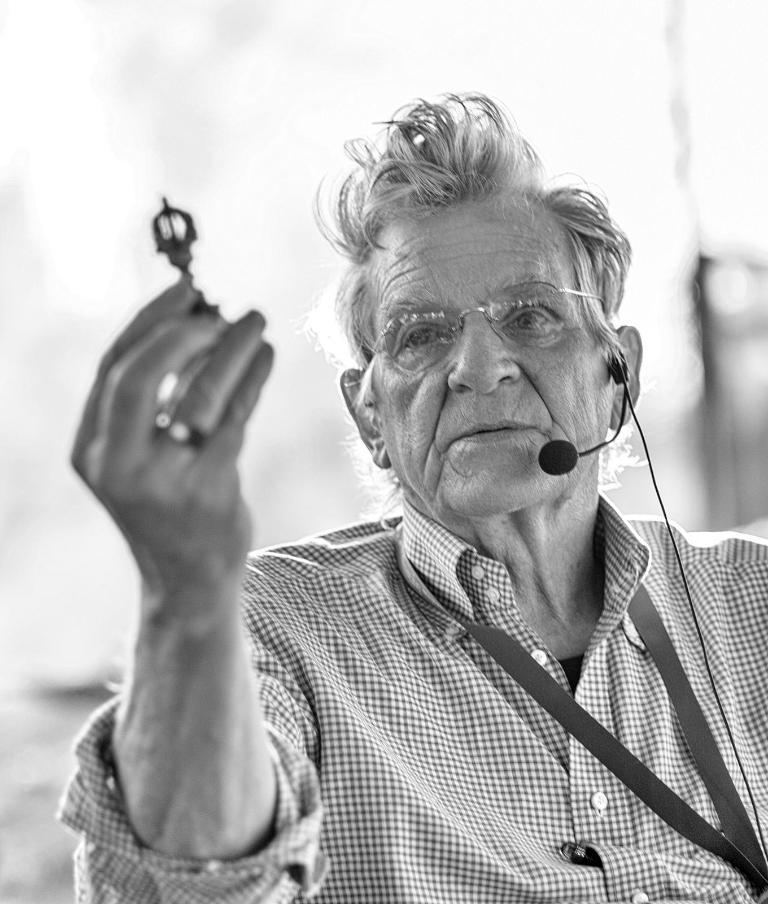What is the color scheme of the image? The image is black and white. Who is the main subject in the image? There is an old man in the image. What is the old man wearing? The old man is wearing a checkered shirt. What objects is the old man holding in the image? The old man is holding a microphone (mic) and a key. How many family members are visible in the image? There is no family member visible in the image besides the old man. What is the health status of the old man in the image? The image does not provide any information about the old man's health status. 